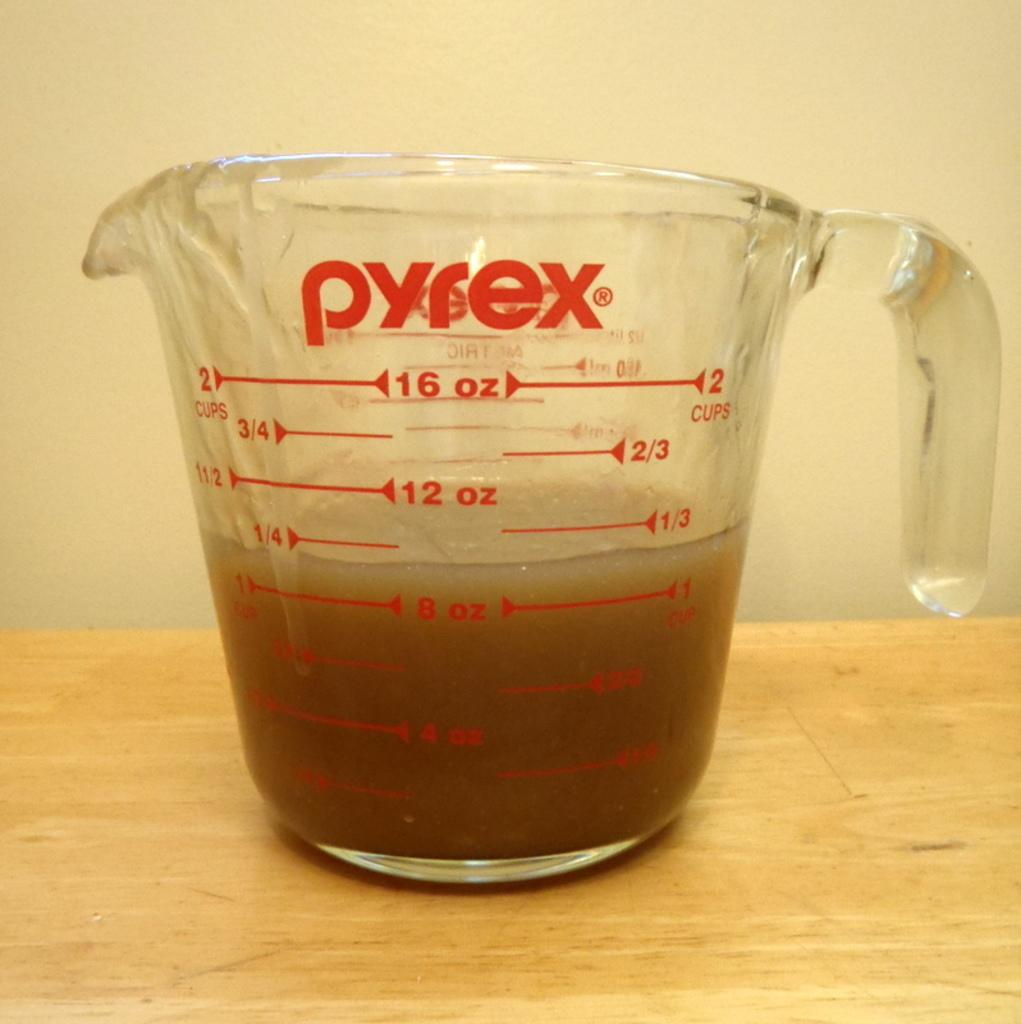<image>
Write a terse but informative summary of the picture. A Pyrex glass measuring cup with liquid filled to almost a 1/4 of a cup. 